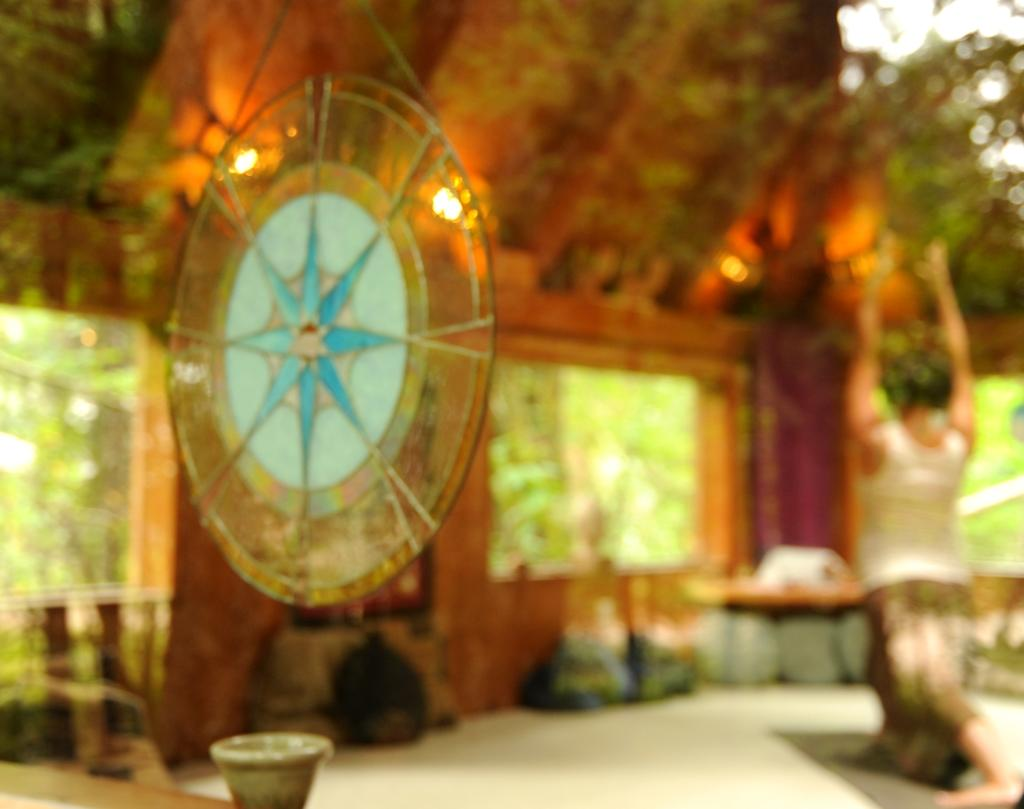Who is the main subject in the image? There is a woman in the image. What is the woman doing in the image? The woman is doing yoga. Can you describe what is hanging at the top of the image? Unfortunately, the provided facts do not mention anything hanging at the top of the image. How does the secretary feel about the police in the image? There is no secretary or police present in the image, so it is not possible to determine their feelings or interactions. 